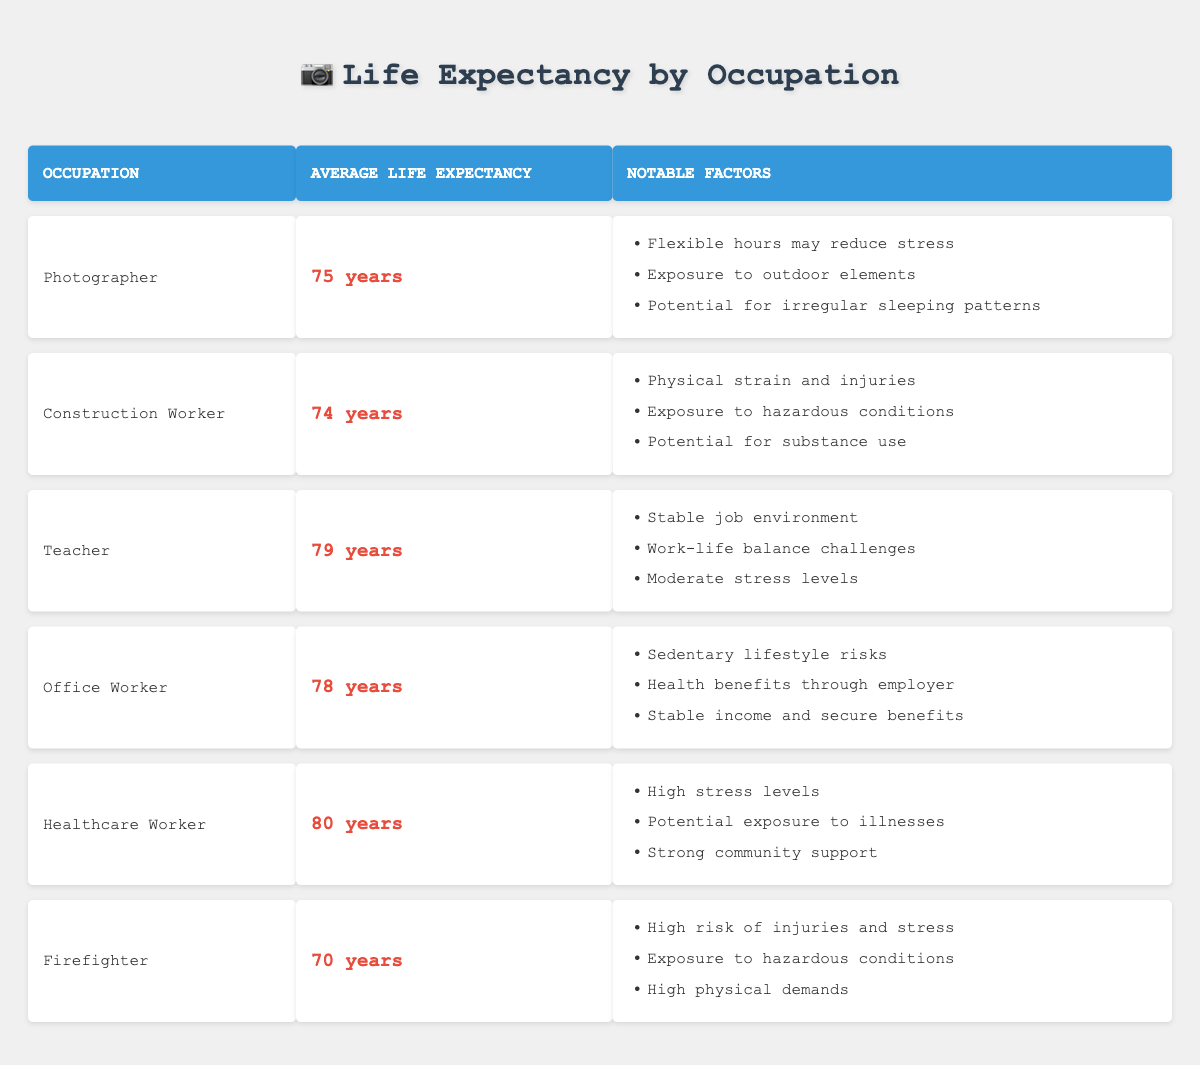What is the average life expectancy of a Photographer? The table lists the average life expectancy of a Photographer as 75 years, which can be found in the second row and second column of the table.
Answer: 75 years Which occupation has the highest average life expectancy? By examining the "Average Life Expectancy" column, the Healthcare Worker has the highest average life expectancy at 80 years, which is the highest value compared to the other occupations.
Answer: Healthcare Worker Is the average life expectancy of a Construction Worker greater than that of a Firefighter? The average life expectancy of a Construction Worker is 74 years, and for a Firefighter, it is 70 years. Since 74 is greater than 70, the statement is true.
Answer: Yes What is the difference in life expectancy between a Photographer and a Teacher? The life expectancy for a Photographer is 75 years, while for a Teacher it is 79 years. The difference is calculated as 79 - 75 = 4 years.
Answer: 4 years Do Office Workers have a shorter average life expectancy than Healthcare Workers? The average life expectancy of an Office Worker is 78 years, while that of a Healthcare Worker is 80 years. Since 78 is less than 80, the statement is true.
Answer: Yes If we consider all occupations, what is the average life expectancy? To find the average, add all the life expectancies: 75 + 74 + 79 + 78 + 80 + 70 = 456. Then, divide by the number of occupations, which is 6: 456 / 6 = 76 years.
Answer: 76 years Are the notable factors for the Healthcare Worker related to high stress levels? Yes, one of the notable factors for Healthcare Workers is "High stress levels," which indicates that stress is indeed a significant factor influencing their life expectancy.
Answer: Yes Which occupation is associated with the lowest average life expectancy, and what is that expectancy? The occupation with the lowest average life expectancy is Firefighter at 70 years, which is mentioned in the last row of the table.
Answer: Firefighter, 70 years 